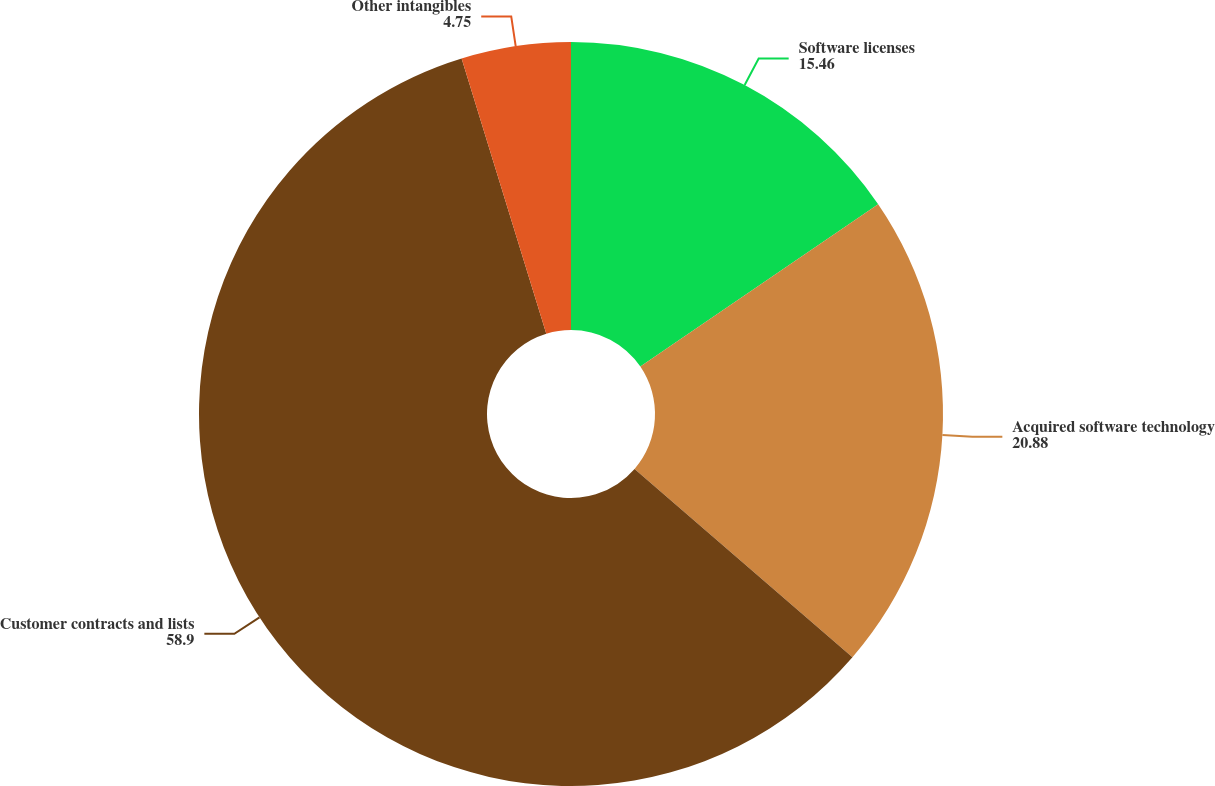Convert chart. <chart><loc_0><loc_0><loc_500><loc_500><pie_chart><fcel>Software licenses<fcel>Acquired software technology<fcel>Customer contracts and lists<fcel>Other intangibles<nl><fcel>15.46%<fcel>20.88%<fcel>58.9%<fcel>4.75%<nl></chart> 